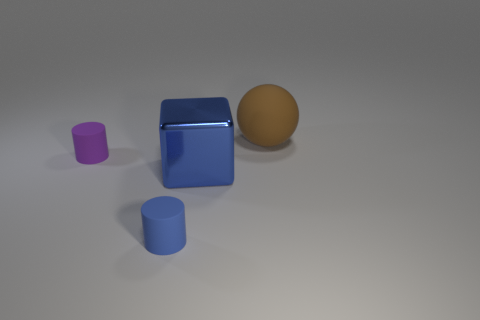Add 2 cubes. How many objects exist? 6 Subtract all blue cylinders. How many cylinders are left? 1 Subtract all spheres. How many objects are left? 3 Add 4 small blue matte cylinders. How many small blue matte cylinders exist? 5 Subtract 0 red cubes. How many objects are left? 4 Subtract 1 balls. How many balls are left? 0 Subtract all green cylinders. Subtract all red balls. How many cylinders are left? 2 Subtract all gray balls. How many blue cylinders are left? 1 Subtract all small purple rubber cylinders. Subtract all red cubes. How many objects are left? 3 Add 1 big brown spheres. How many big brown spheres are left? 2 